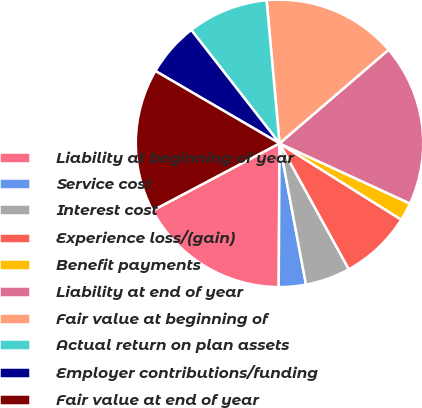<chart> <loc_0><loc_0><loc_500><loc_500><pie_chart><fcel>Liability at beginning of year<fcel>Service cost<fcel>Interest cost<fcel>Experience loss/(gain)<fcel>Benefit payments<fcel>Liability at end of year<fcel>Fair value at beginning of<fcel>Actual return on plan assets<fcel>Employer contributions/funding<fcel>Fair value at end of year<nl><fcel>17.16%<fcel>3.04%<fcel>5.06%<fcel>8.08%<fcel>2.03%<fcel>18.17%<fcel>15.14%<fcel>9.09%<fcel>6.07%<fcel>16.15%<nl></chart> 